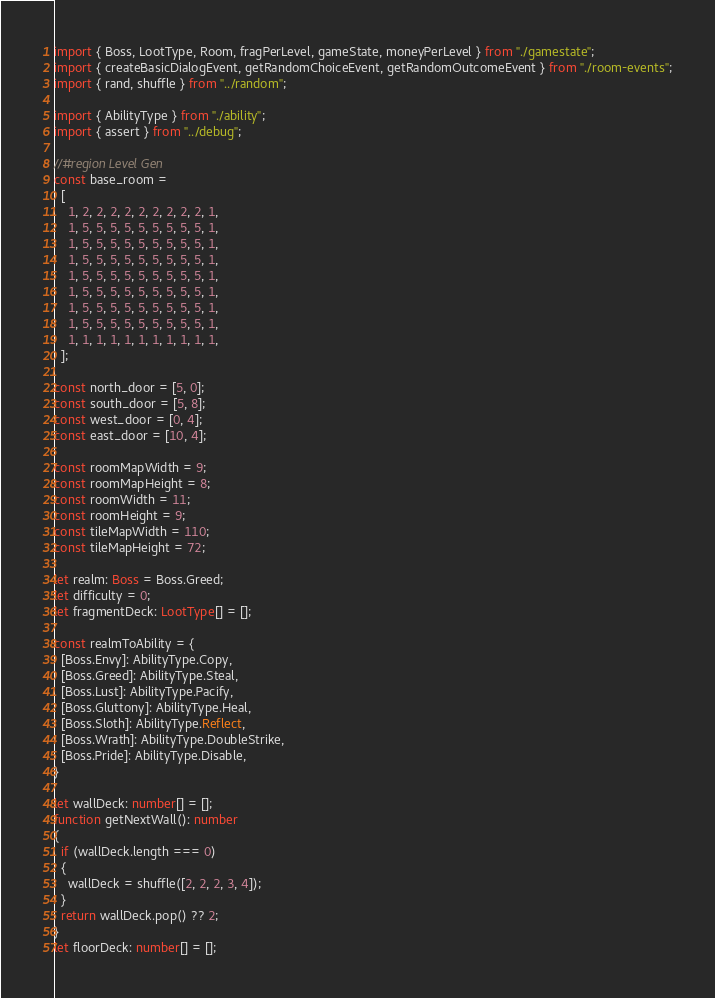Convert code to text. <code><loc_0><loc_0><loc_500><loc_500><_TypeScript_>import { Boss, LootType, Room, fragPerLevel, gameState, moneyPerLevel } from "./gamestate";
import { createBasicDialogEvent, getRandomChoiceEvent, getRandomOutcomeEvent } from "./room-events";
import { rand, shuffle } from "../random";

import { AbilityType } from "./ability";
import { assert } from "../debug";

//#region Level Gen
const base_room =
  [
    1, 2, 2, 2, 2, 2, 2, 2, 2, 2, 1,
    1, 5, 5, 5, 5, 5, 5, 5, 5, 5, 1,
    1, 5, 5, 5, 5, 5, 5, 5, 5, 5, 1,
    1, 5, 5, 5, 5, 5, 5, 5, 5, 5, 1,
    1, 5, 5, 5, 5, 5, 5, 5, 5, 5, 1,
    1, 5, 5, 5, 5, 5, 5, 5, 5, 5, 1,
    1, 5, 5, 5, 5, 5, 5, 5, 5, 5, 1,
    1, 5, 5, 5, 5, 5, 5, 5, 5, 5, 1,
    1, 1, 1, 1, 1, 1, 1, 1, 1, 1, 1,
  ];

const north_door = [5, 0];
const south_door = [5, 8];
const west_door = [0, 4];
const east_door = [10, 4];

const roomMapWidth = 9;
const roomMapHeight = 8;
const roomWidth = 11;
const roomHeight = 9;
const tileMapWidth = 110;
const tileMapHeight = 72;

let realm: Boss = Boss.Greed;
let difficulty = 0;
let fragmentDeck: LootType[] = [];

const realmToAbility = {
  [Boss.Envy]: AbilityType.Copy,
  [Boss.Greed]: AbilityType.Steal,
  [Boss.Lust]: AbilityType.Pacify,
  [Boss.Gluttony]: AbilityType.Heal,
  [Boss.Sloth]: AbilityType.Reflect,
  [Boss.Wrath]: AbilityType.DoubleStrike,
  [Boss.Pride]: AbilityType.Disable,
}

let wallDeck: number[] = [];
function getNextWall(): number
{
  if (wallDeck.length === 0)
  {
    wallDeck = shuffle([2, 2, 2, 3, 4]);
  }
  return wallDeck.pop() ?? 2;
}
let floorDeck: number[] = [];</code> 